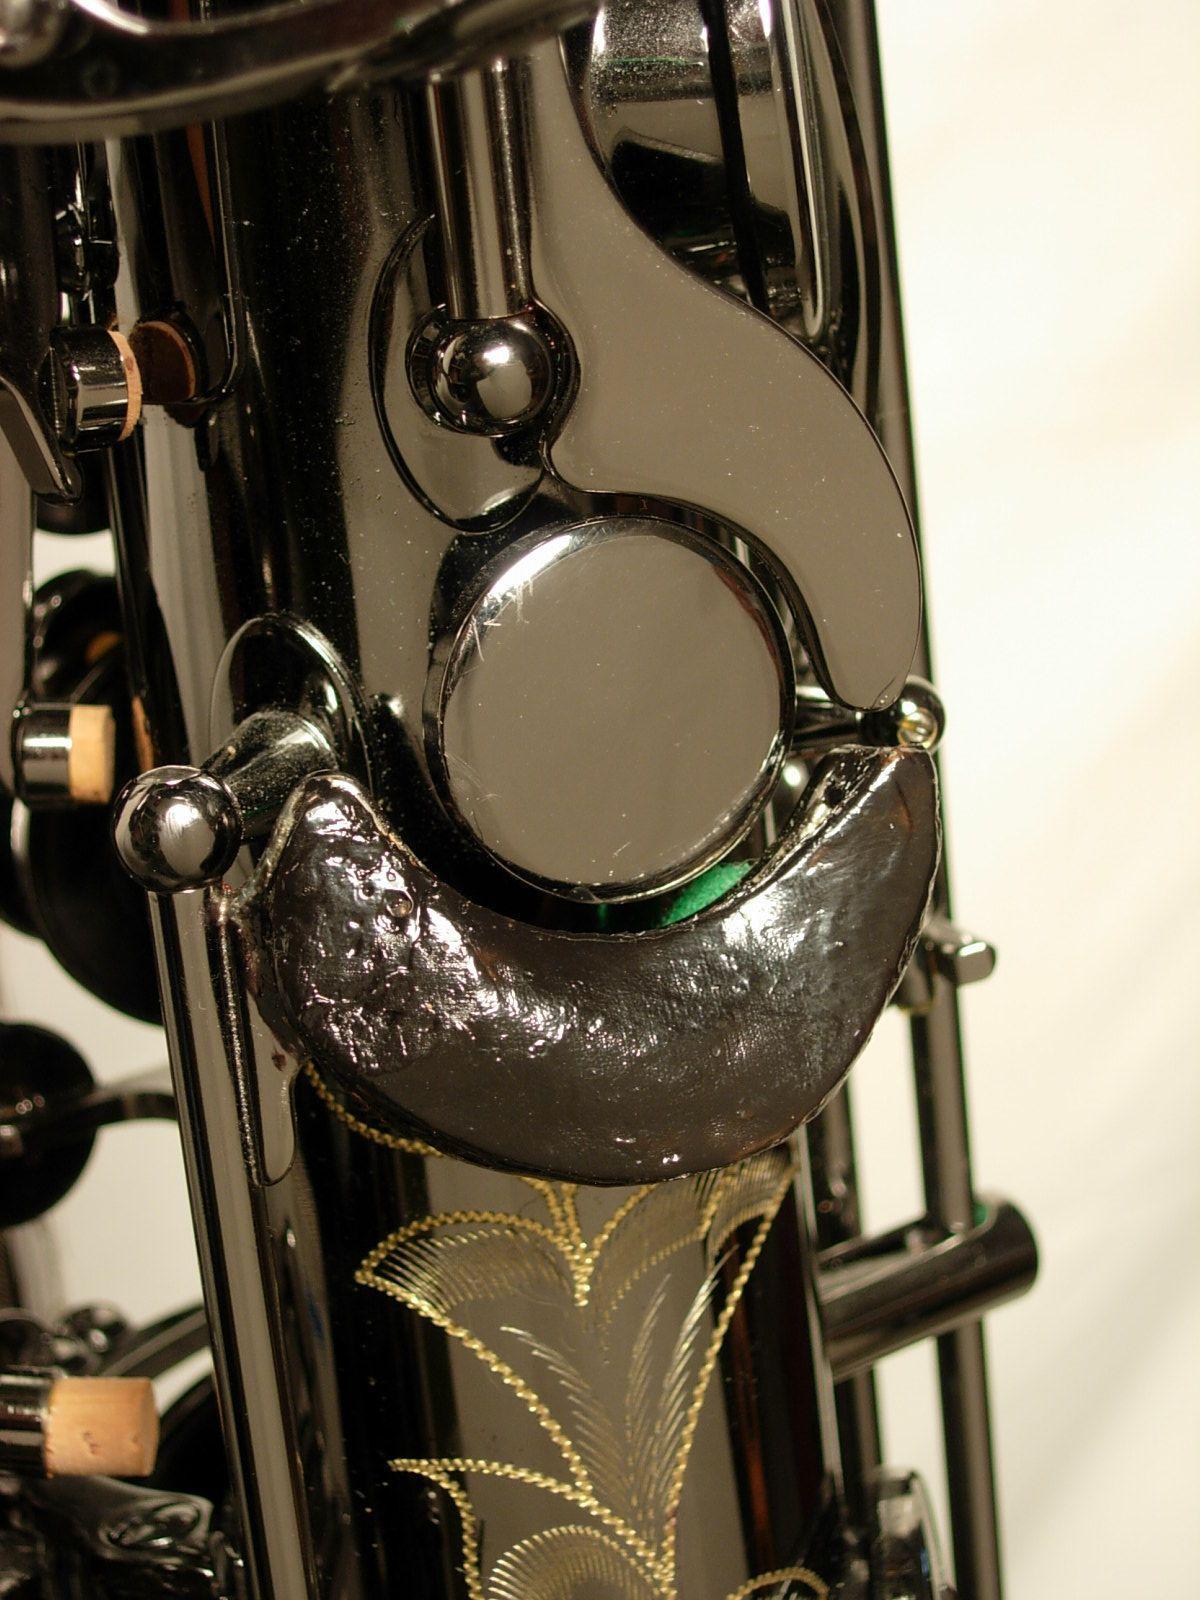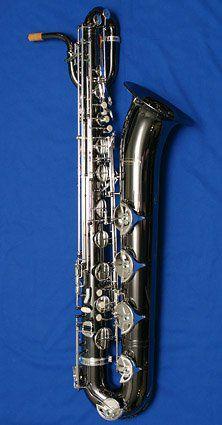The first image is the image on the left, the second image is the image on the right. Assess this claim about the two images: "The left image shows an upright saxophone with its bell facing right, and the right image features one saxophone that is gold-colored.". Correct or not? Answer yes or no. No. The first image is the image on the left, the second image is the image on the right. Considering the images on both sides, is "The left and right image contains the same number of  fully sized saxophones." valid? Answer yes or no. No. 